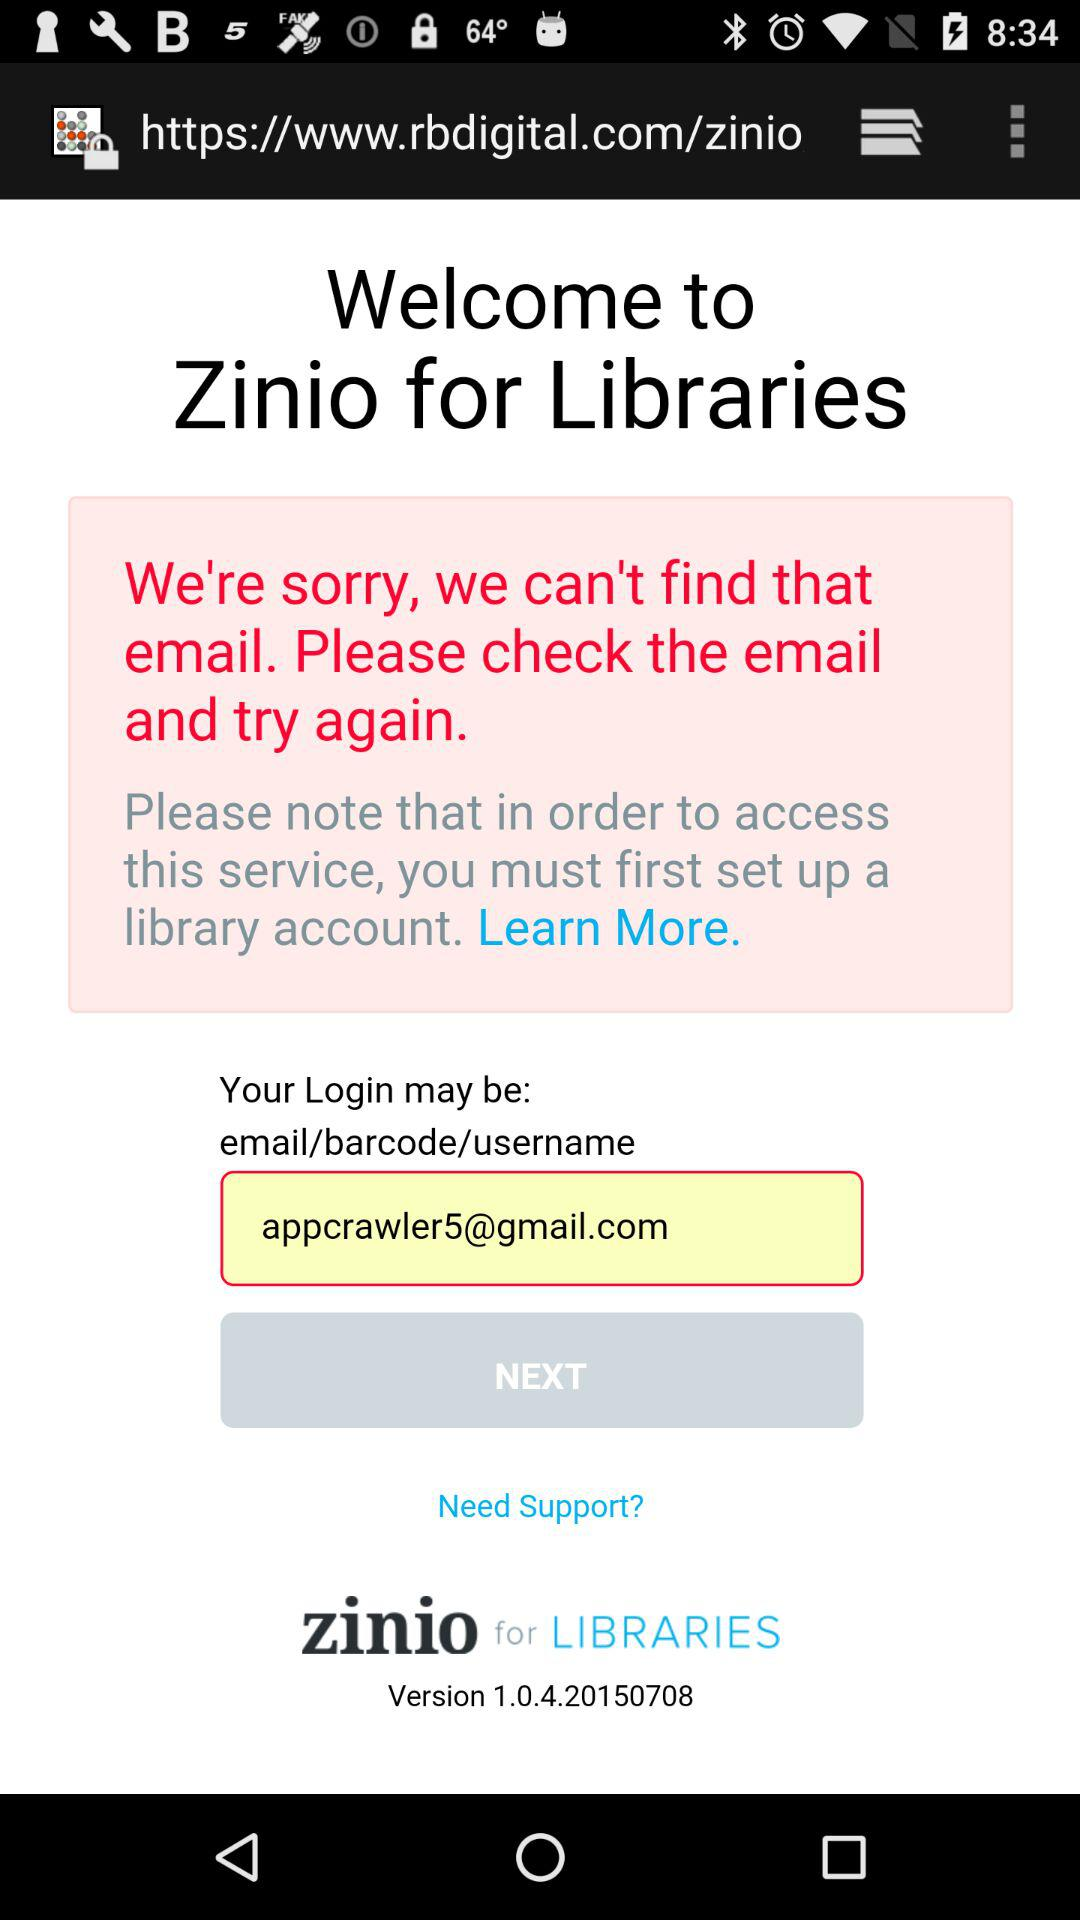What is the username?
When the provided information is insufficient, respond with <no answer>. <no answer> 